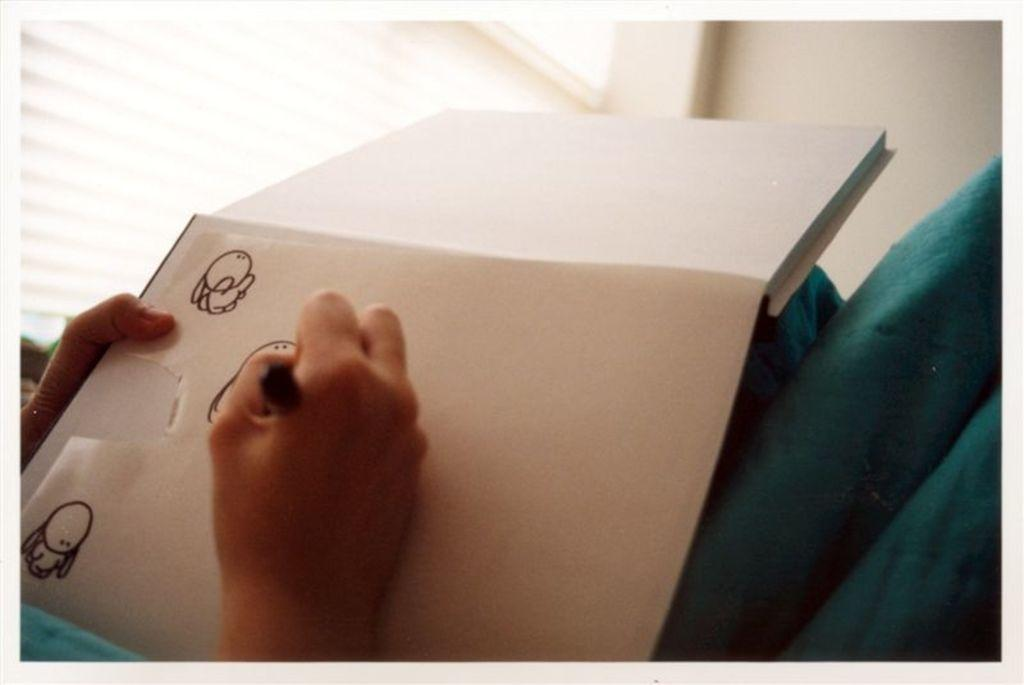What is the person in the image doing? The person is drawing in a book. Can you describe the location of the window in the image? The window is to the left of the person. What can be seen in the background of the image? The background of the image includes a white wall. How many bananas are hanging on the wall in the image? There are no bananas present in the image; the background includes a white wall. 